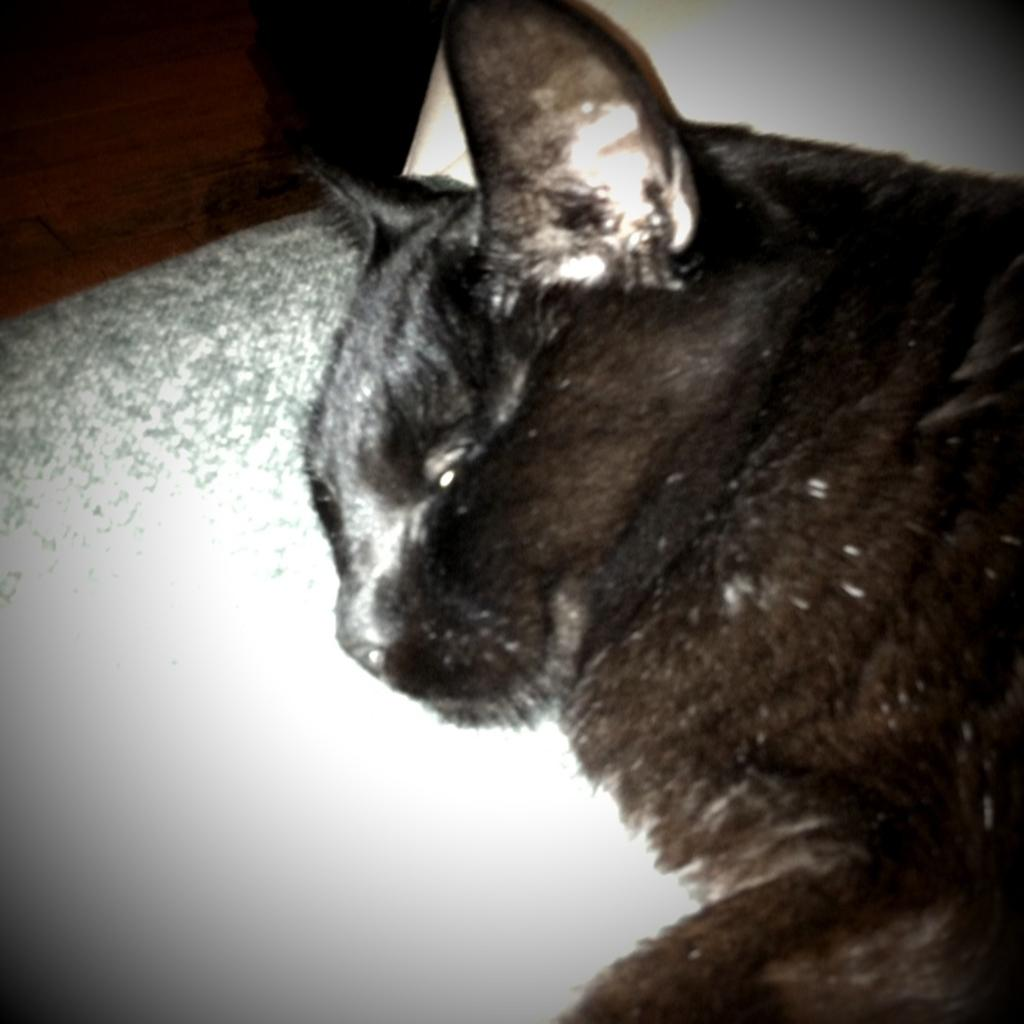What animal is present in the image? There is a cat in the image. What is the cat doing in the image? The cat is sleeping. Where is the cat located in the image? The cat is on a pillow. What type of expert advice can be heard from the cat in the image? There is no expert advice being given by the cat in the image, as it is sleeping. 